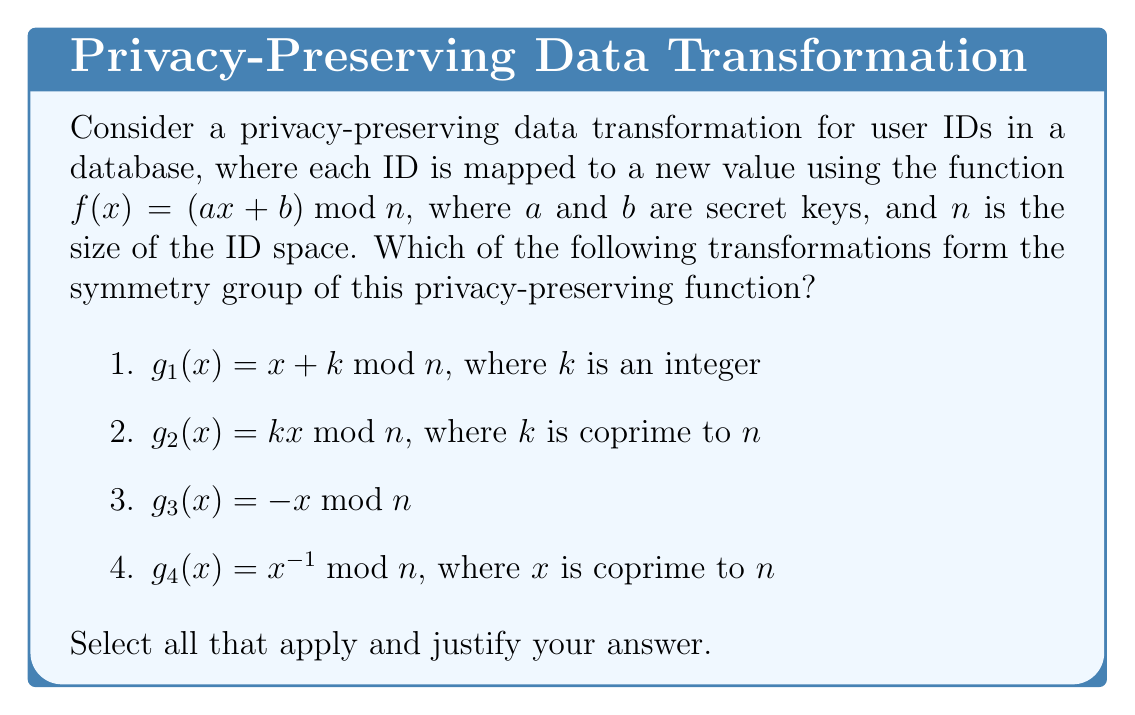Can you answer this question? To determine which transformations form the symmetry group of the privacy-preserving function $f(x) = (ax + b) \bmod n$, we need to check which transformations commute with $f$ and preserve its structure. Let's analyze each transformation:

1. $g_1(x) = x + k \bmod n$:
   Let's check if $f(g_1(x)) = g_1(f(x))$:
   
   $f(g_1(x)) = a(x + k) + b \bmod n = (ax + ak + b) \bmod n$
   $g_1(f(x)) = (ax + b) + k \bmod n = (ax + b + k) \bmod n$
   
   These are equal for all $x$, so $g_1$ is in the symmetry group.

2. $g_2(x) = kx \bmod n$, where $k$ is coprime to $n$:
   Let's check if $f(g_2(x)) = g_2(f(x))$:
   
   $f(g_2(x)) = a(kx) + b \bmod n = (akx + b) \bmod n$
   $g_2(f(x)) = k(ax + b) \bmod n = (kax + kb) \bmod n$
   
   These are not equal in general, so $g_2$ is not in the symmetry group.

3. $g_3(x) = -x \bmod n$:
   Let's check if $f(g_3(x)) = g_3(f(x))$:
   
   $f(g_3(x)) = a(-x) + b \bmod n = (-ax + b) \bmod n$
   $g_3(f(x)) = -(ax + b) \bmod n = (-ax - b) \bmod n$
   
   These are not equal in general, so $g_3$ is not in the symmetry group.

4. $g_4(x) = x^{-1} \bmod n$, where $x$ is coprime to $n$:
   Let's check if $f(g_4(x)) = g_4(f(x))$:
   
   $f(g_4(x)) = a(x^{-1}) + b \bmod n$
   $g_4(f(x)) = (ax + b)^{-1} \bmod n$
   
   These are not equal in general, so $g_4$ is not in the symmetry group.

Therefore, only $g_1(x) = x + k \bmod n$ forms the symmetry group of the privacy-preserving function $f(x) = (ax + b) \bmod n$. This group is isomorphic to the cyclic group $\mathbb{Z}_n$ under addition modulo $n$.
Answer: $g_1(x) = x + k \bmod n$ 